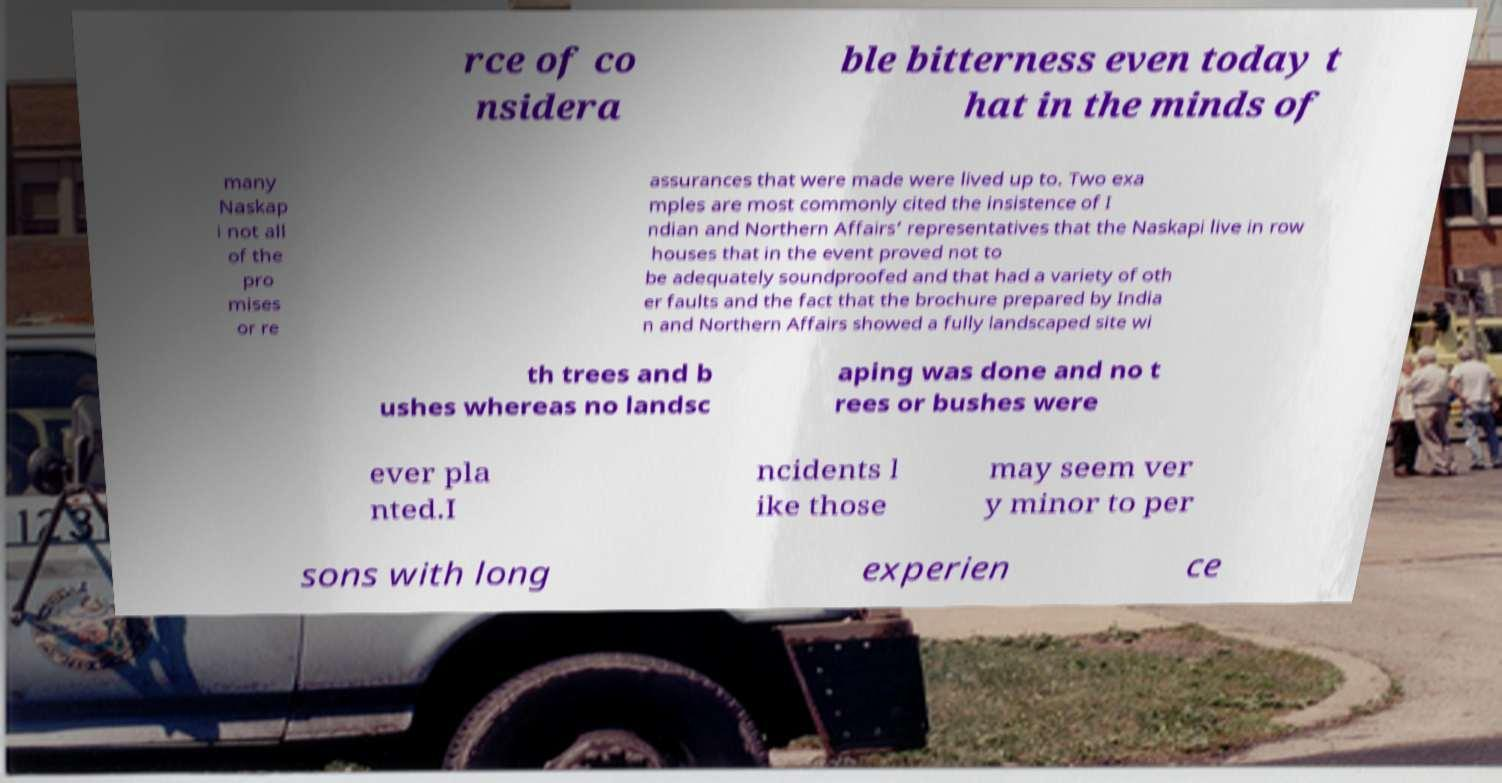Please identify and transcribe the text found in this image. rce of co nsidera ble bitterness even today t hat in the minds of many Naskap i not all of the pro mises or re assurances that were made were lived up to. Two exa mples are most commonly cited the insistence of I ndian and Northern Affairs’ representatives that the Naskapi live in row houses that in the event proved not to be adequately soundproofed and that had a variety of oth er faults and the fact that the brochure prepared by India n and Northern Affairs showed a fully landscaped site wi th trees and b ushes whereas no landsc aping was done and no t rees or bushes were ever pla nted.I ncidents l ike those may seem ver y minor to per sons with long experien ce 